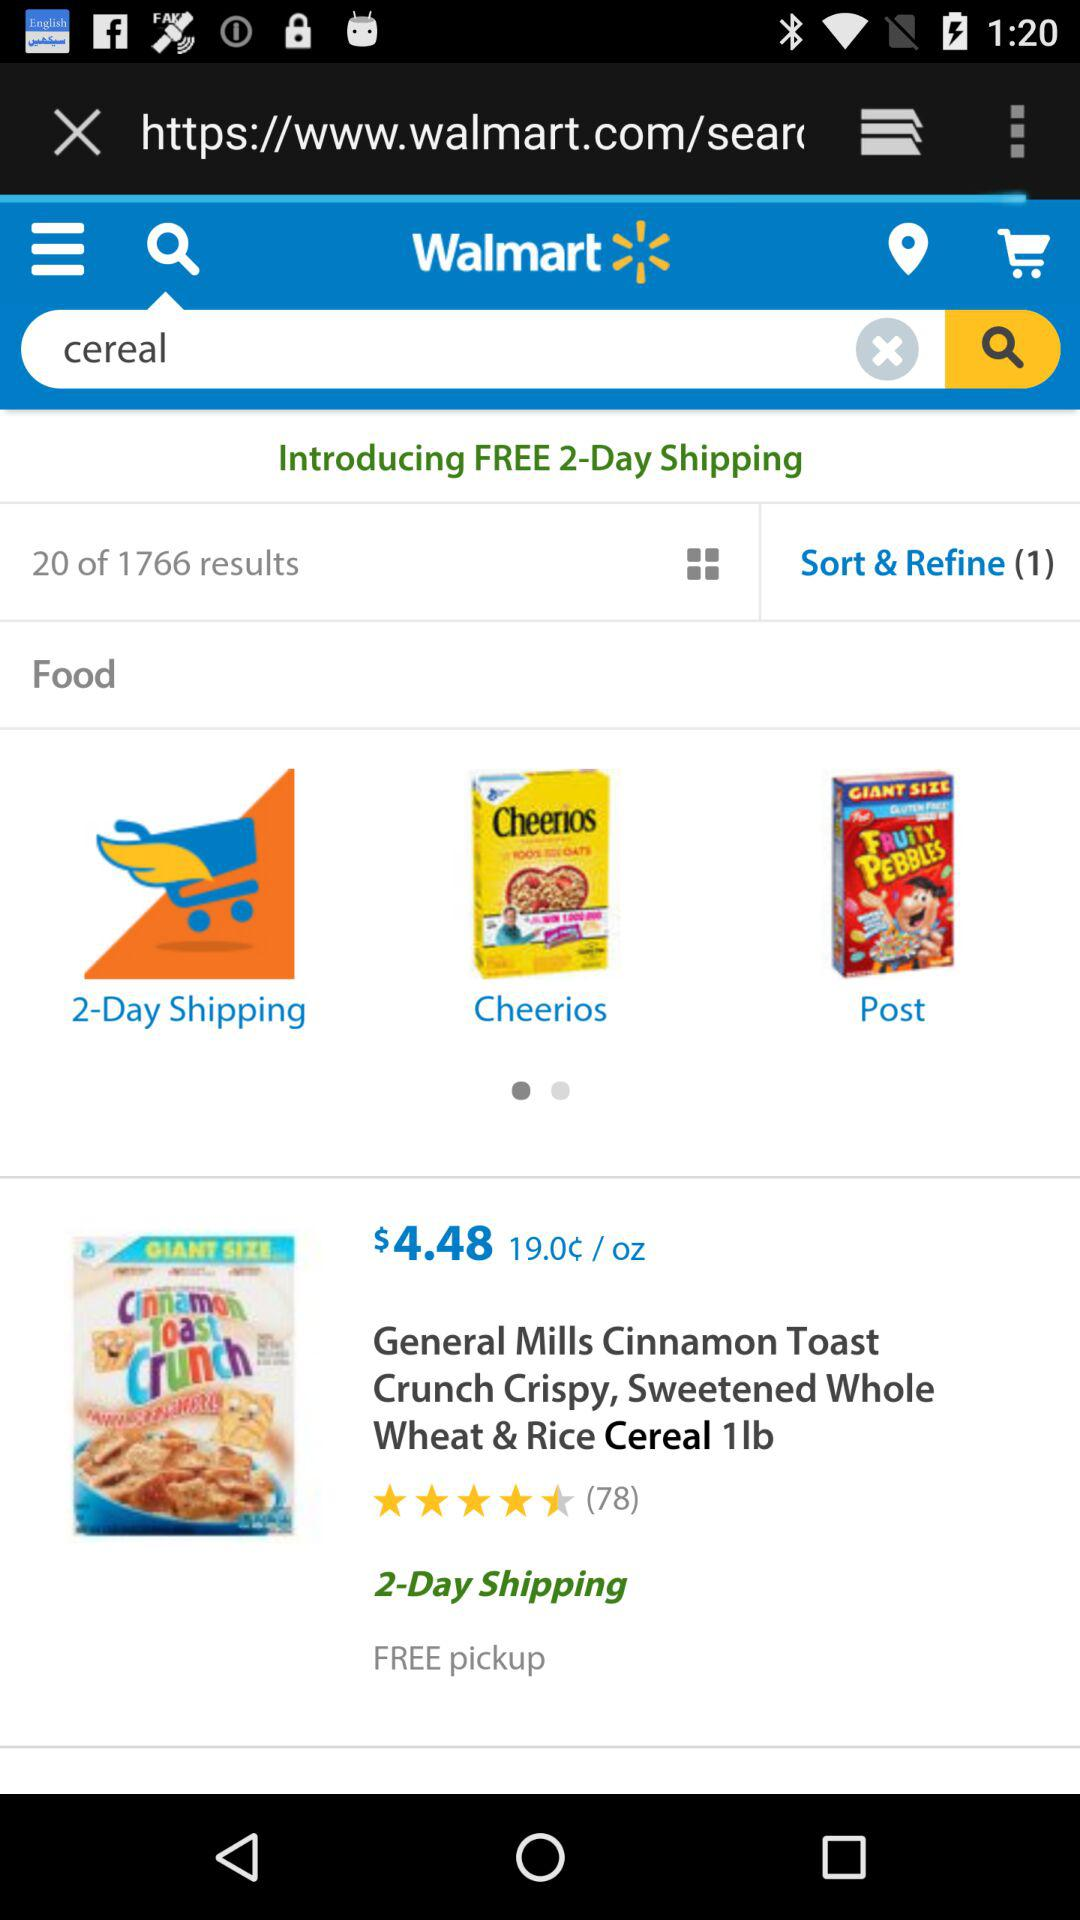What's the number of "Sort & Refine"? The number of "Sort & Refine" is 1. 